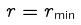<formula> <loc_0><loc_0><loc_500><loc_500>r = r _ { \min }</formula> 